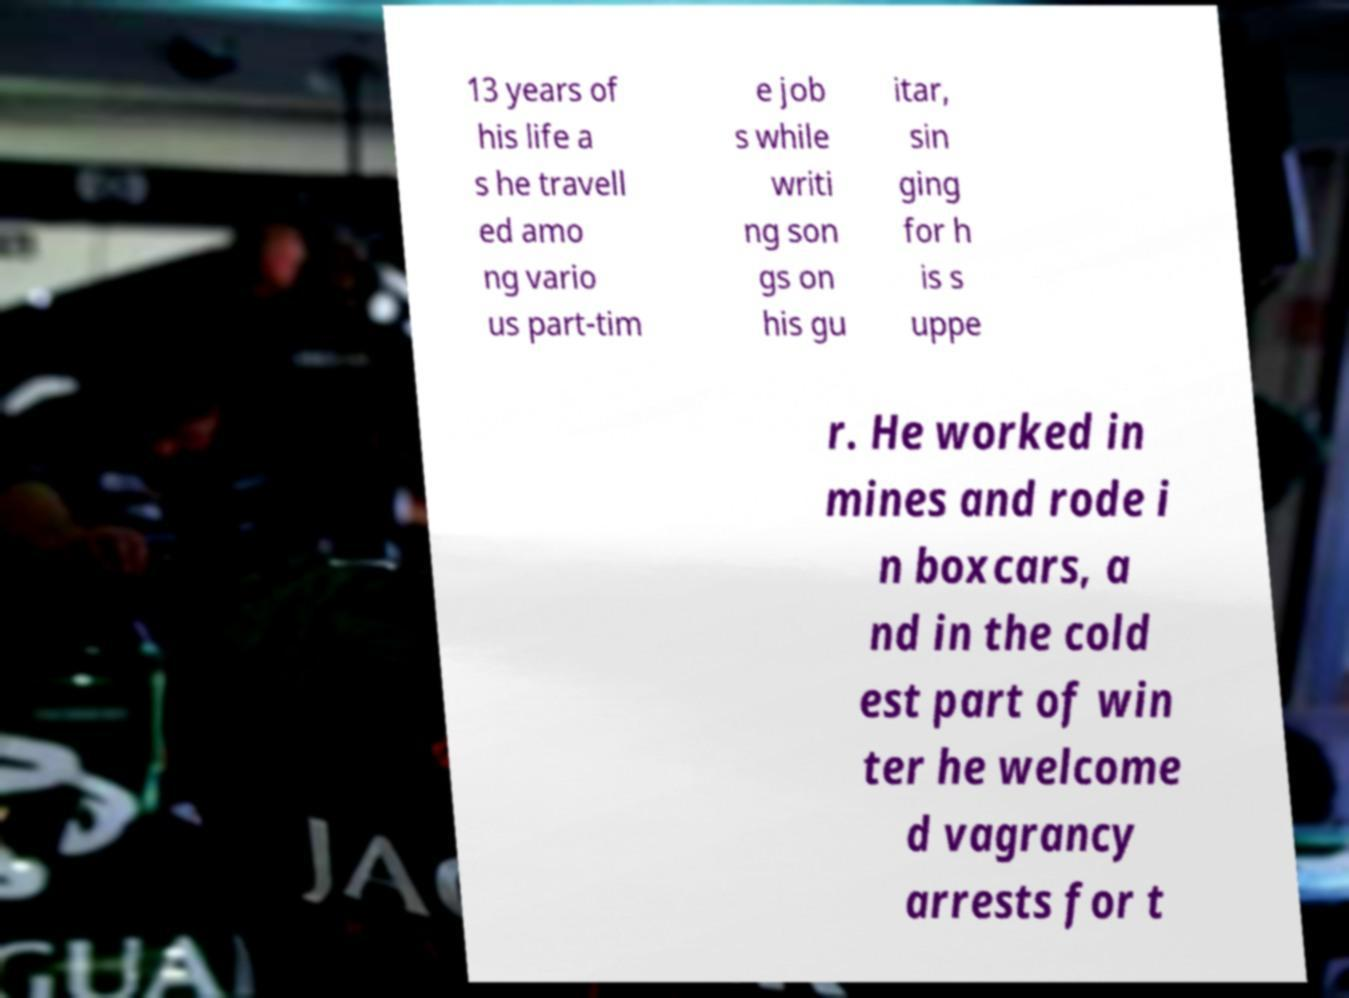For documentation purposes, I need the text within this image transcribed. Could you provide that? 13 years of his life a s he travell ed amo ng vario us part-tim e job s while writi ng son gs on his gu itar, sin ging for h is s uppe r. He worked in mines and rode i n boxcars, a nd in the cold est part of win ter he welcome d vagrancy arrests for t 